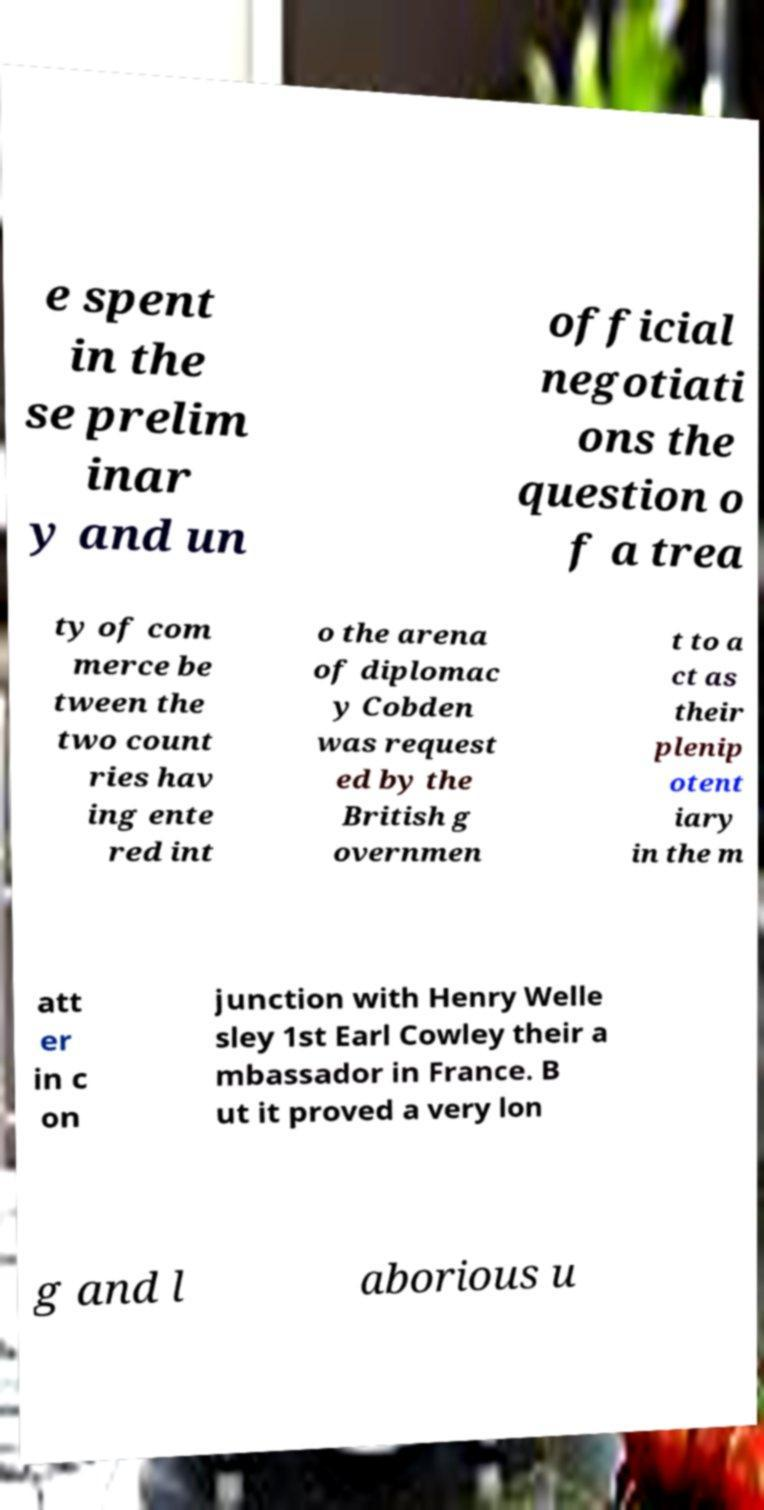There's text embedded in this image that I need extracted. Can you transcribe it verbatim? e spent in the se prelim inar y and un official negotiati ons the question o f a trea ty of com merce be tween the two count ries hav ing ente red int o the arena of diplomac y Cobden was request ed by the British g overnmen t to a ct as their plenip otent iary in the m att er in c on junction with Henry Welle sley 1st Earl Cowley their a mbassador in France. B ut it proved a very lon g and l aborious u 